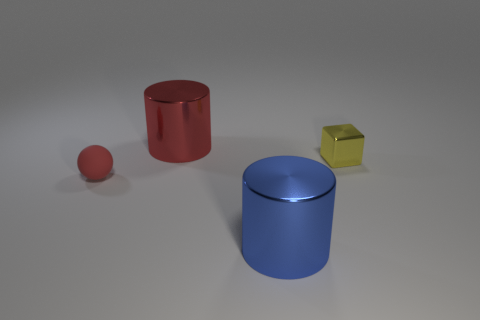Can you describe the lighting and shadows in the scene? The scene is illuminated by a light source from above that casts soft shadows directly underneath the objects. The shadows provide a sense of depth and dimension to the objects within the scene, emphasizing their volume. 